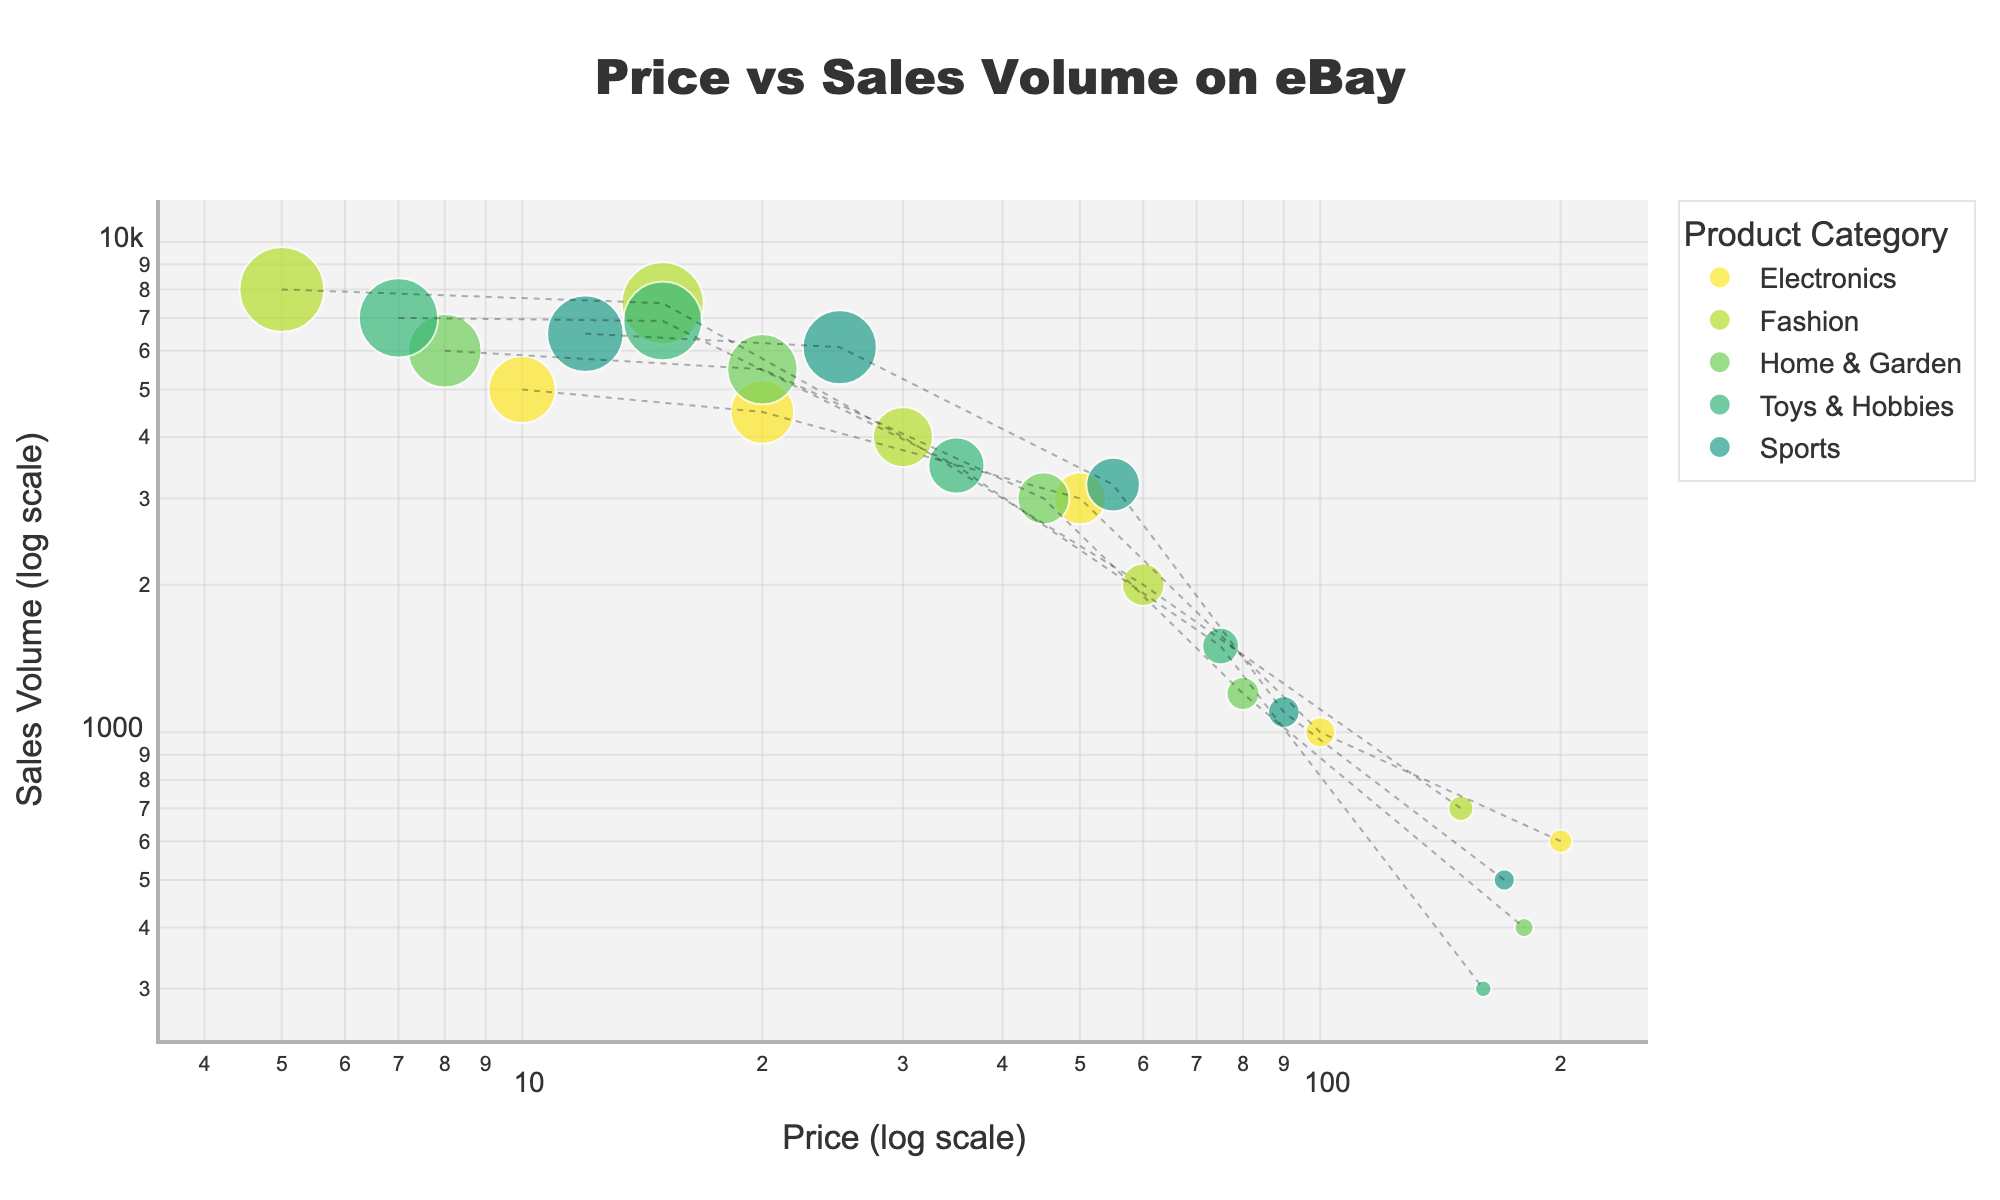How many unique product categories are shown in the plot? By looking at the legend in the plot, we can see distinct colors representing each product category. Count the number of different categories listed.
Answer: 5 What is the title of the scatter plot? Check the top-center of the plot where the title is usually displayed.
Answer: Price vs Sales Volume on eBay Which category has the highest sales volume at the lowest price point? Identify the lowest price point on the x-axis (log scale) and find the corresponding data point with the highest y-value (sales volume). Check the category label or color for that data point.
Answer: Fashion What is the range of prices for Electronics? Locate the Electronics category data points on the plot. Note the minimum and maximum prices by looking at their positions on the x-axis (log scale).
Answer: 10 to 200 Which two categories have data points with the same sales volume of 3000? Find the y-axis value of 3000 in the plot. Identify the categories of the data points that align with this value.
Answer: Electronics and Home & Garden If the price of a product in the Sports category is doubled from 25, what is the sales volume trend observed in the plot? Locate the data point in the Sports category with a price of 25. Then, find the data point with the next available price roughly double that (around 50). Compare their sales volumes.
Answer: Decreases from 6100 to 3200 Which category has the steepest decline in sales volume as price increases? Visually trace the trend lines added for each category. Identify the category where the slope of the line is the steepest downward as prices increase on the log scale.
Answer: Electronics For the price range of $75, which category has the highest sales volume? Locate the vertical line corresponding to the price of 75 on the x-axis (log scale). Identify which category has the highest point (y-axis value) at this price level.
Answer: Toys & Hobbies What's the average sales volume for the data points in the Home & Garden category? Collect the sales volume values for Home & Garden: 6000, 5500, 3000, 1200, 400. Calculate the sum and then divide by the number of data points: (6000 + 5500 + 3000 + 1200 + 400) / 5.
Answer: 3220 Which category has fewer data points but a more consistent trend in sales volume as price increases? Count the number of data points for each category and observe the trend lines. Identify the category with fewer points and a less varied sales volume pattern.
Answer: Sports 